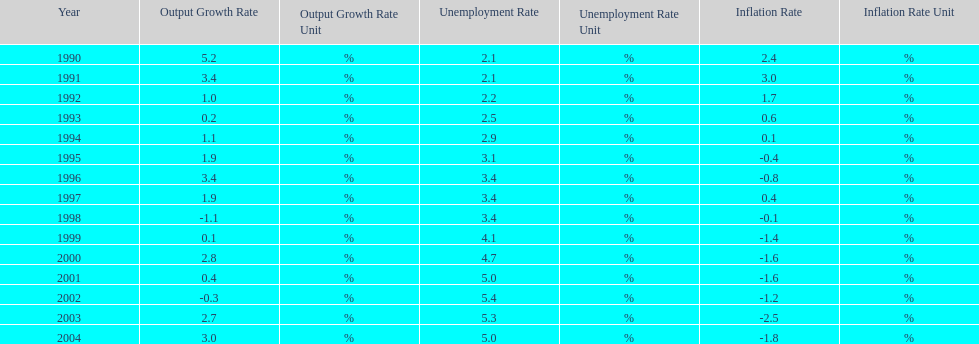In what years, between 1990 and 2004, did japan's unemployment rate reach 5% or higher? 4. 